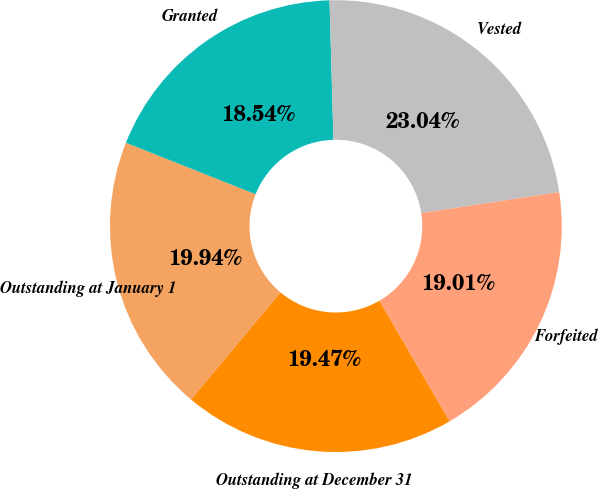<chart> <loc_0><loc_0><loc_500><loc_500><pie_chart><fcel>Outstanding at January 1<fcel>Granted<fcel>Vested<fcel>Forfeited<fcel>Outstanding at December 31<nl><fcel>19.94%<fcel>18.54%<fcel>23.04%<fcel>19.01%<fcel>19.47%<nl></chart> 